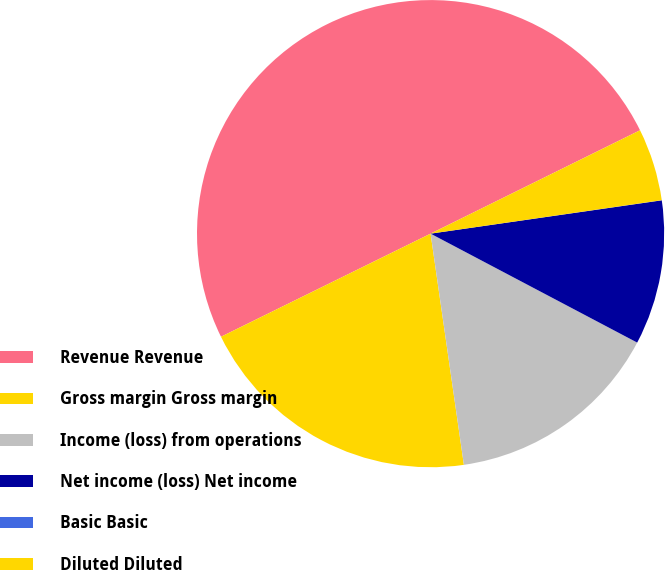Convert chart to OTSL. <chart><loc_0><loc_0><loc_500><loc_500><pie_chart><fcel>Revenue Revenue<fcel>Gross margin Gross margin<fcel>Income (loss) from operations<fcel>Net income (loss) Net income<fcel>Basic Basic<fcel>Diluted Diluted<nl><fcel>49.98%<fcel>20.0%<fcel>15.0%<fcel>10.0%<fcel>0.01%<fcel>5.01%<nl></chart> 